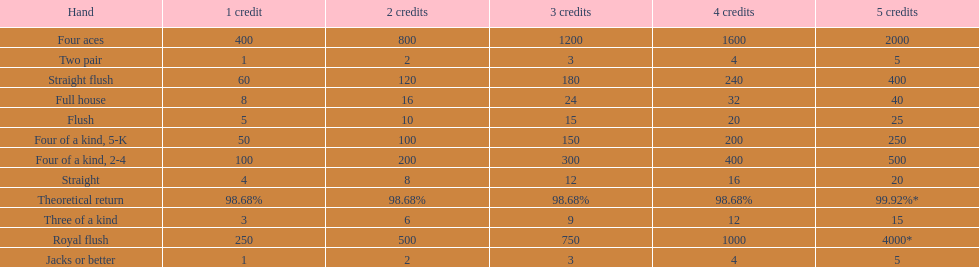At most, what could a person earn for having a full house? 40. 